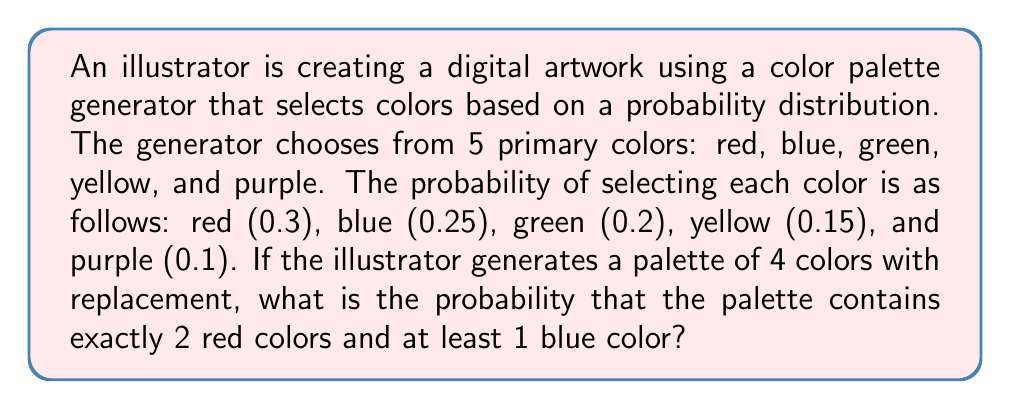Give your solution to this math problem. Let's approach this step-by-step:

1) First, we need to calculate the probability of getting exactly 2 red colors out of 4 selections. This follows a binomial distribution:

   $$P(\text{2 red}) = \binom{4}{2} (0.3)^2 (0.7)^2 = 6 \cdot 0.09 \cdot 0.49 = 0.2646$$

2) Now, we need to calculate the probability of getting at least 1 blue color in the remaining 2 selections. It's easier to calculate the probability of getting no blue colors and subtract from 1:

   $$P(\text{at least 1 blue in 2 selections}) = 1 - P(\text{no blue in 2 selections})$$
   $$= 1 - (0.75)^2 = 1 - 0.5625 = 0.4375$$

3) However, these 2 blue selections could be in any of the 4 positions, not just the remaining 2. So we need to consider all possibilities:

   a) 2 red, 2 non-red (with at least 1 blue)
   b) 2 red, 1 blue, 1 other color
   c) 2 red, 2 blue

4) For case a:
   $$P(a) = \binom{4}{2} (0.3)^2 (0.45)^2 \cdot 0.4375 = 6 \cdot 0.09 \cdot 0.2025 \cdot 0.4375 = 0.047953125$$

5) For case b:
   $$P(b) = \binom{4}{2} \cdot \binom{2}{1} \cdot (0.3)^2 \cdot 0.25 \cdot 0.45 = 12 \cdot 0.09 \cdot 0.25 \cdot 0.45 = 0.12150$$

6) For case c:
   $$P(c) = \binom{4}{2} (0.3)^2 (0.25)^2 = 6 \cdot 0.09 \cdot 0.0625 = 0.033750$$

7) The total probability is the sum of these three cases:

   $$P(\text{total}) = P(a) + P(b) + P(c) = 0.047953125 + 0.12150 + 0.033750 = 0.203203125$$
Answer: 0.203203125 